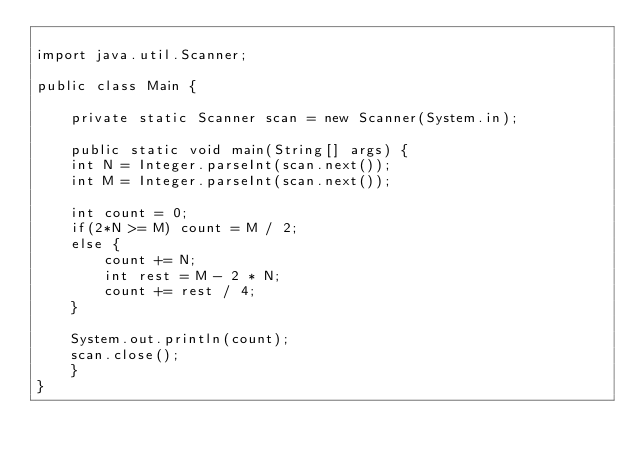<code> <loc_0><loc_0><loc_500><loc_500><_Java_>
import java.util.Scanner;

public class Main {

    private static Scanner scan = new Scanner(System.in);

    public static void main(String[] args) {
	int N = Integer.parseInt(scan.next());
	int M = Integer.parseInt(scan.next());

	int count = 0;
	if(2*N >= M) count = M / 2;
	else {
	    count += N;
	    int rest = M - 2 * N;
	    count += rest / 4;
	}

	System.out.println(count);
	scan.close();
    }
}
</code> 